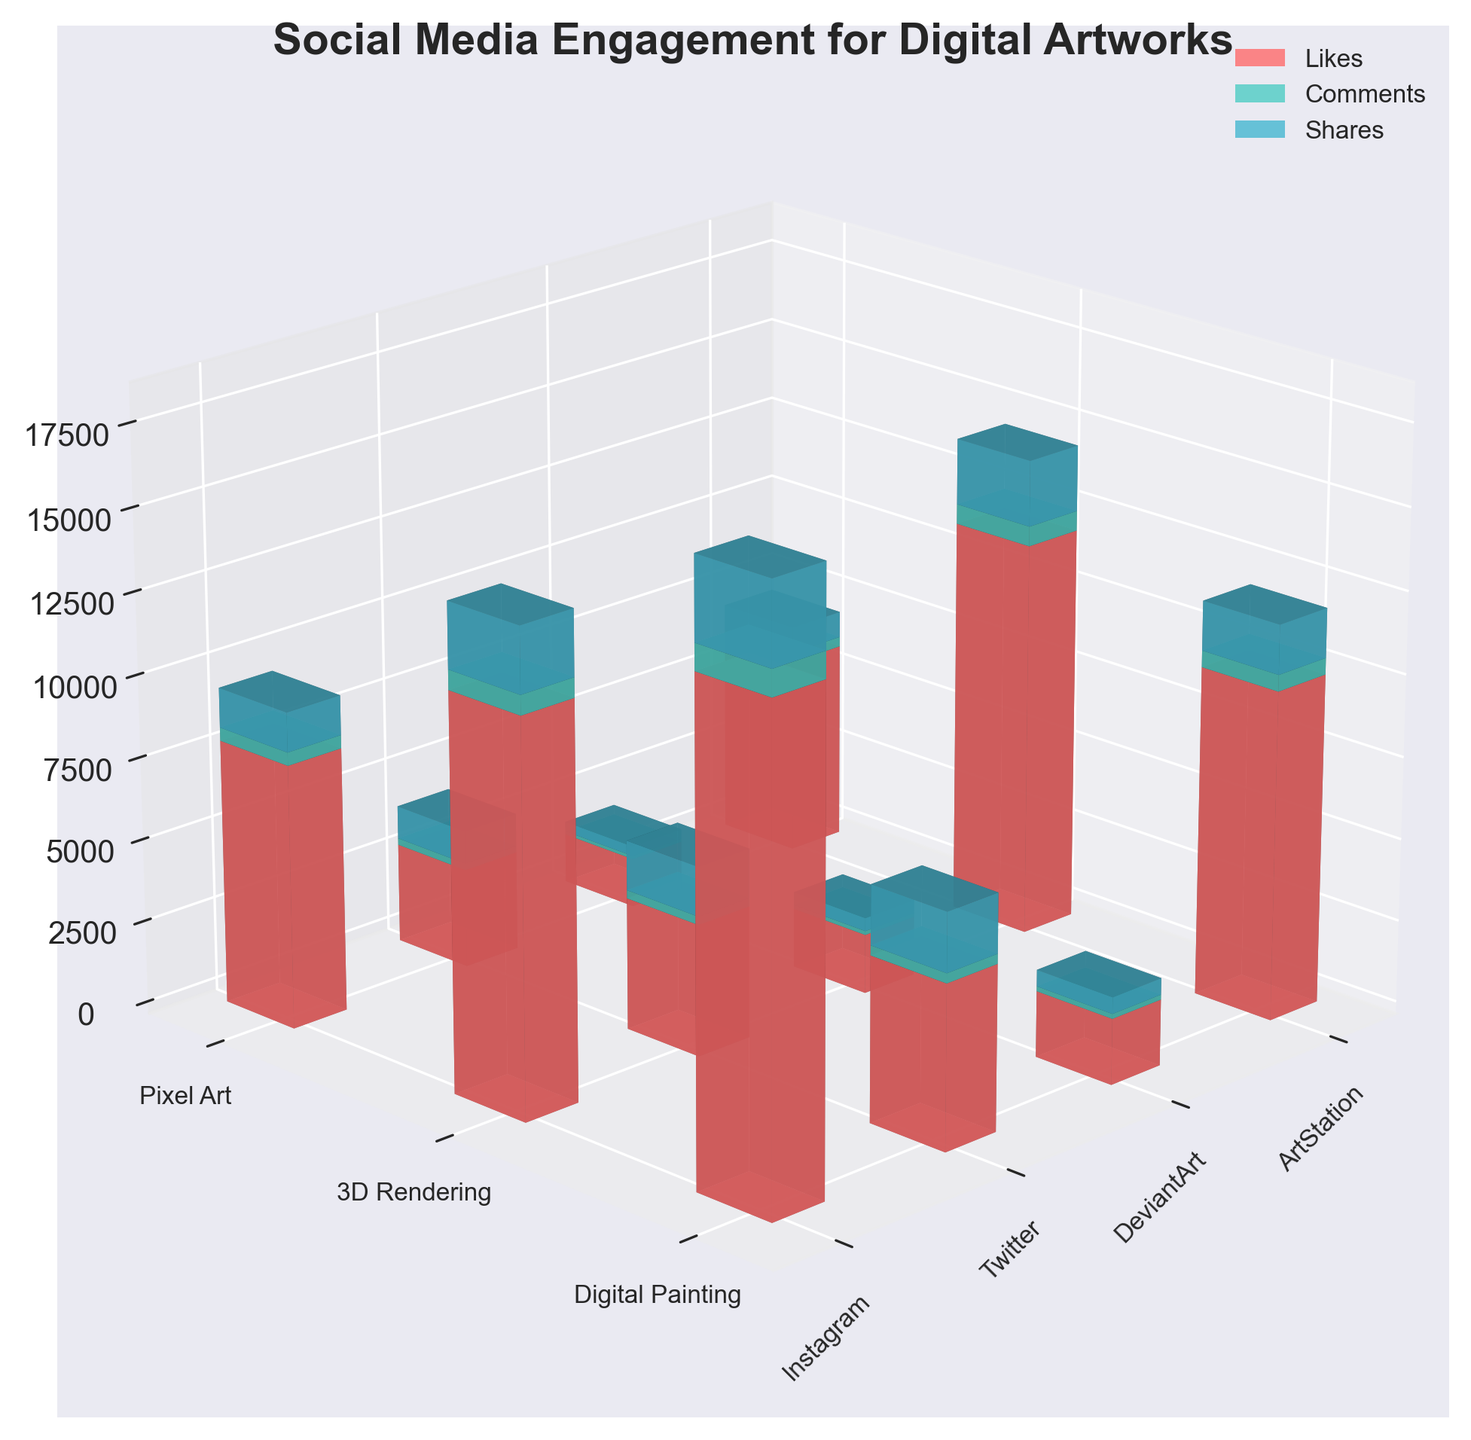What is the title of the figure? The title is located at the top of the figure and usually specifies what the data represents. By referring to the top, it states "Social Media Engagement for Digital Artworks".
Answer: Social Media Engagement for Digital Artworks Which artwork style received the most 'Likes' on Instagram? Look for the tallest red bar representing 'Likes' in the Instagram section. Digital Painting has the tallest bar for 'Likes'.
Answer: Digital Painting How many platforms are included in this figure? There are four distinct xtick labels representing the platforms: Instagram, Twitter, DeviantArt, ArtStation.
Answer: 4 What is the order of artwork styles sorted by 'Comments' on Twitter from highest to lowest? Identify the green bars under Twitter and compare their heights. Digital Painting has the highest, followed by 3D Rendering, then Pixel Art based on 'Comments'.
Answer: Digital Painting, 3D Rendering, Pixel Art Which platform has the highest overall engagement (sum of Likes, Comments, Shares) for 3D Rendering? Sum up the heights of the three bars (red for Likes, green for Comments, blue for Shares) under each platform for 3D Rendering. ArtStation has the sum of 3800.
Answer: ArtStation Does Pixel Art receive more 'Shares' on Twitter or DeviantArt? Compare the heights of the blue bars representing 'Shares' for Pixel Art on Twitter and DeviantArt. Twitter’s bar is taller with 1000 'Shares'.
Answer: Twitter What is the combined number of 'Shares' for Digital Painting on all platforms? Sum the heights of the blue bars for 'Shares' in Digital Painting across all platforms (Instagram: 2500, Twitter: 1800, DeviantArt: 500, ArtStation: 1500). This results in 2500+1800+500+1500 = 6300.
Answer: 6300 Which artwork style has the lowest average engagement (average of Likes, Comments, Shares) across all platforms? Calculate the average engagement for each style by summing the metrics (Likes, Comments, Shares) and dividing by 3, then compare the averages. Pixel Art results in the lowest when dividing its sum by 3.
Answer: Pixel Art Which engagement metric sees the most variation across different platforms for Digital Painting? Examine the red, green, and blue bars for Digital Painting across platforms, and determine which has the most significant height difference. 'Likes' (red bars) show the most variation from 2000 to 15000.
Answer: Likes 